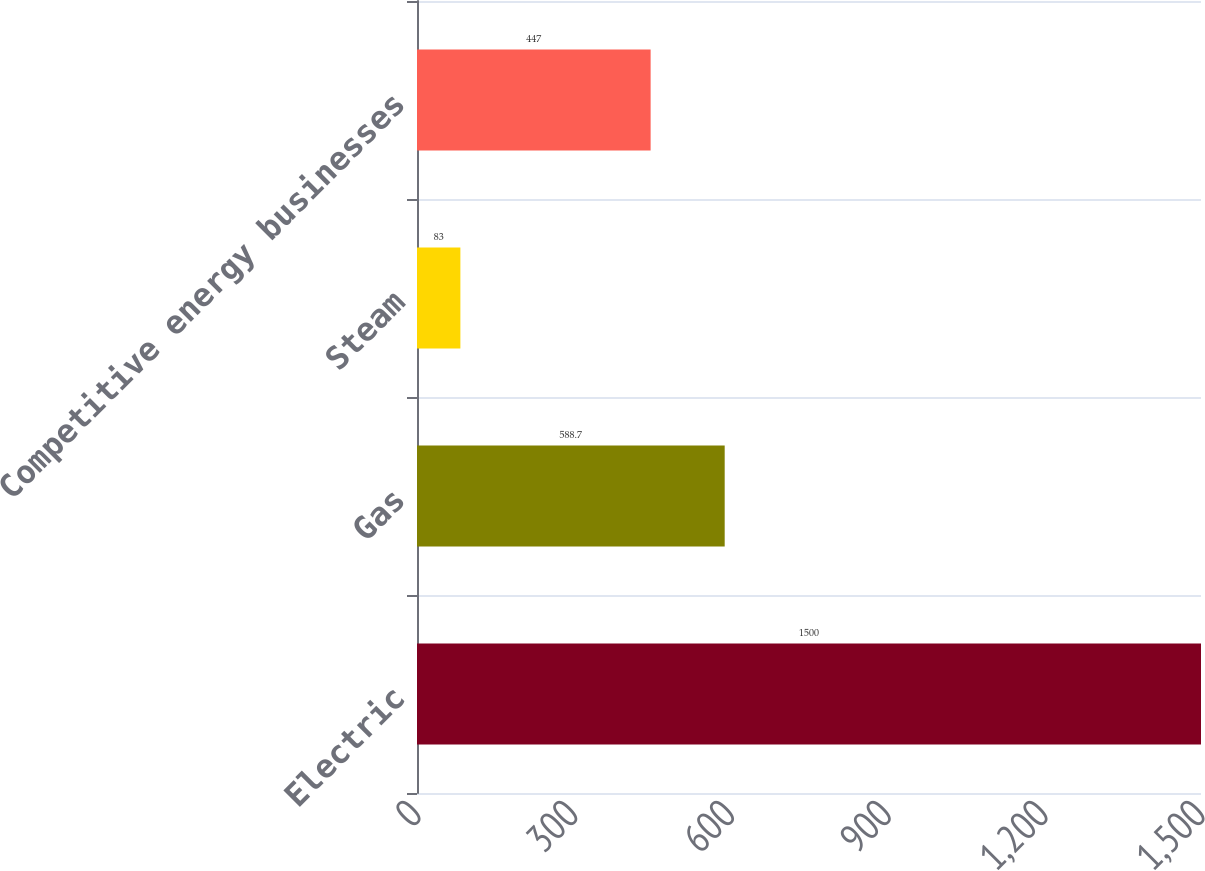<chart> <loc_0><loc_0><loc_500><loc_500><bar_chart><fcel>Electric<fcel>Gas<fcel>Steam<fcel>Competitive energy businesses<nl><fcel>1500<fcel>588.7<fcel>83<fcel>447<nl></chart> 